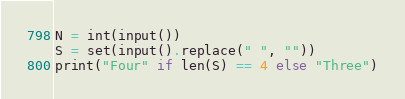Convert code to text. <code><loc_0><loc_0><loc_500><loc_500><_Python_>N = int(input())
S = set(input().replace(" ", ""))
print("Four" if len(S) == 4 else "Three")</code> 